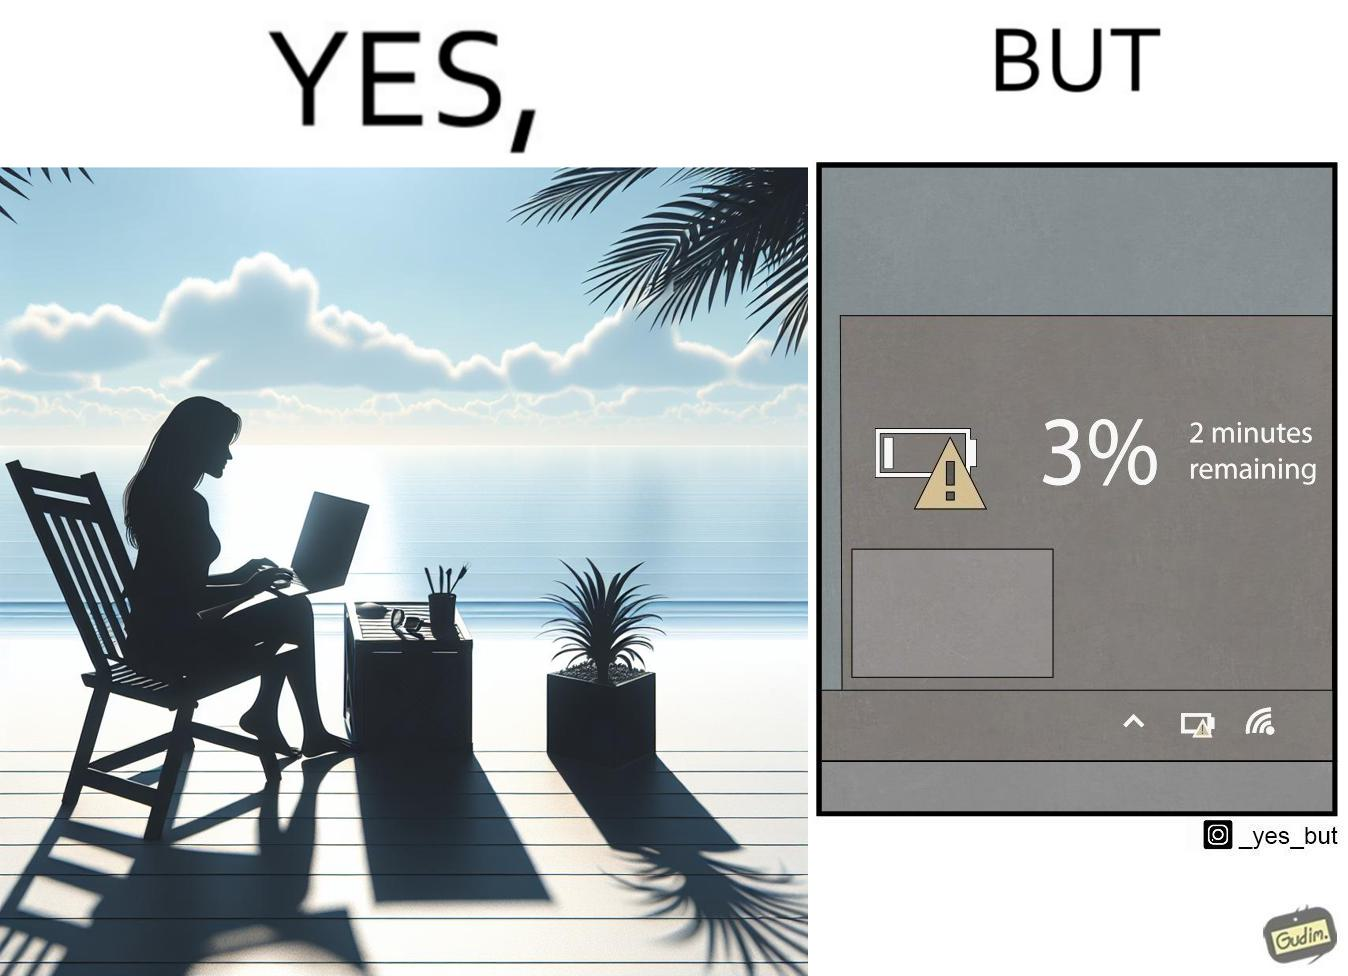Is there satirical content in this image? Yes, this image is satirical. 